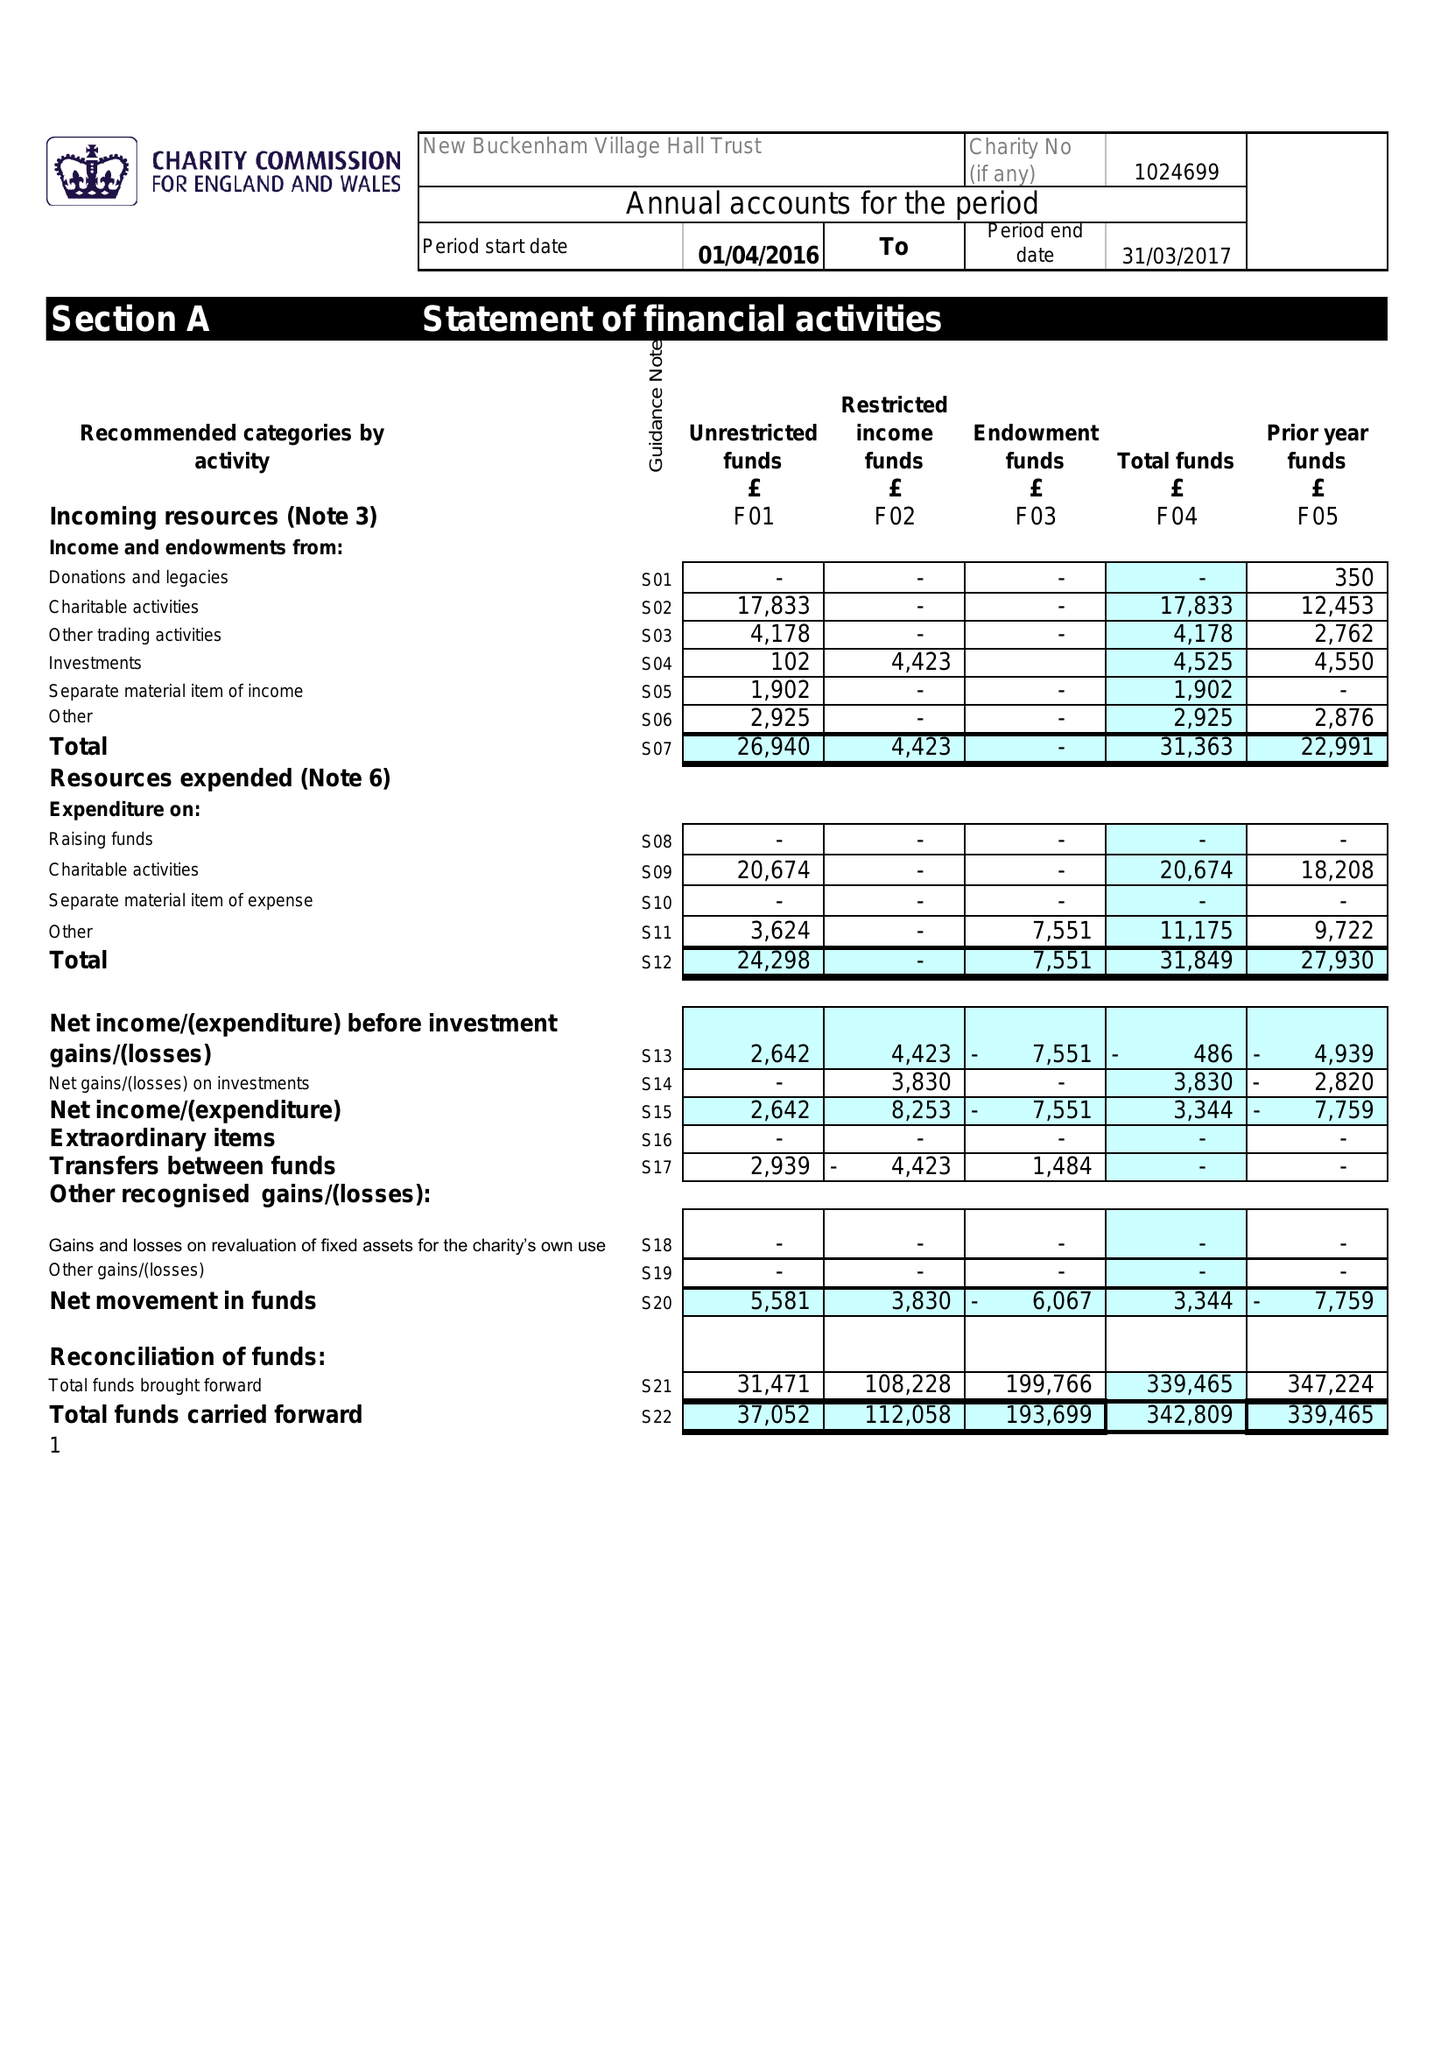What is the value for the charity_number?
Answer the question using a single word or phrase. 1024699 